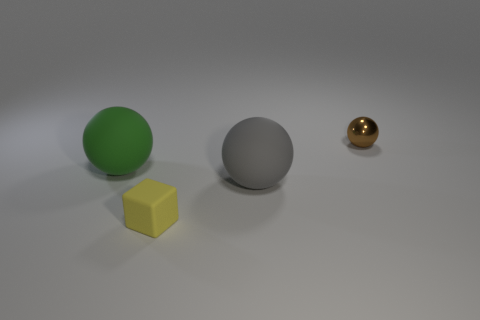Subtract all large rubber balls. How many balls are left? 1 Add 3 tiny gray spheres. How many objects exist? 7 Subtract all blocks. How many objects are left? 3 Subtract 0 red cylinders. How many objects are left? 4 Subtract all tiny rubber objects. Subtract all rubber balls. How many objects are left? 1 Add 2 small spheres. How many small spheres are left? 3 Add 4 small purple rubber objects. How many small purple rubber objects exist? 4 